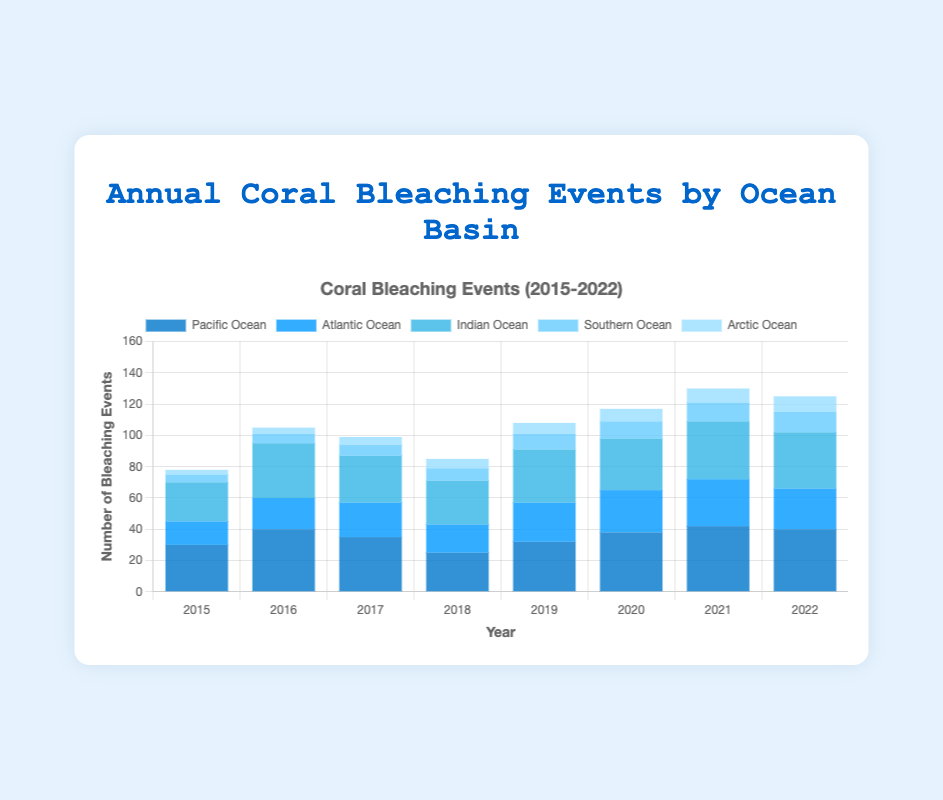Which year had the highest number of coral bleaching events in the Pacific Ocean? Looking at the "Pacific Ocean" values across the years in the figure, the highest value is 42 in 2021.
Answer: 2021 In 2019, which ocean had the fewest coral bleaching events? In 2019, compare the number of bleaching events: Pacific (32), Atlantic (25), Indian (34), Southern (10), Arctic (7). The Arctic Ocean had the fewest with 7 events.
Answer: Arctic Ocean What is the difference in the number of coral bleaching events between the Atlantic Ocean and Indian Ocean in 2020? In 2020, the Atlantic Ocean had 27 events and the Indian Ocean had 33. The difference is 33 - 27 = 6 events.
Answer: 6 Which ocean basin shows an upward trend in coral bleaching events from 2015 to 2022? Observing the trends for each ocean basin from 2015 to 2022: the Southern and Arctic Oceans both show an increasing trend.
Answer: Southern Ocean, Arctic Ocean How many total coral bleaching events occurred in the Southern Ocean in all the years combined (2015-2022)? Sum the values for the Southern Ocean from 2015 to 2022: 5 + 6 + 7 + 8 + 10 + 11 + 12 + 13 = 72.
Answer: 72 In which year did the Atlantic Ocean experience the largest increase in coral bleaching events compared to the previous year? The increases can be calculated as follows: 2016 (20-15=5), 2017 (22-20=2), 2018 (18-22=-4), 2019 (25-18=7), 2020 (27-25=2), 2021 (30-27=3), 2022 (26-30=-4). The largest increase is in 2019 (7 events).
Answer: 2019 Across all years, which ocean had the most consistent number of coral bleaching events (smallest range of values)? Calculate the range (max - min) for each ocean: Pacific (42-25=17), Atlantic (30-15=15), Indian (37-25=12), Southern (13-5=8), Arctic (10-3=7). The Arctic Ocean has the smallest range of 7.
Answer: Arctic Ocean What is the average number of coral bleaching events per year in the Indian Ocean from 2015 to 2022? Sum the values for the Indian Ocean and divide by the number of years: (25 + 35 + 30 + 28 + 34 + 33 + 37 + 36) / 8 = 258 / 8 = 32.25.
Answer: 32.25 Visual comparison: Which ocean basin had the highest bleaching event in 2015, and what was the number? In 2015, the Pacific Ocean's bar is the tallest, indicating 30 events.
Answer: Pacific Ocean, 30 Which two years had the exact same number of coral bleaching events in the Pacific Ocean? Observing the figure, the values for the Pacific Ocean in 2016 and 2022 are both 40.
Answer: 2016, 2022 